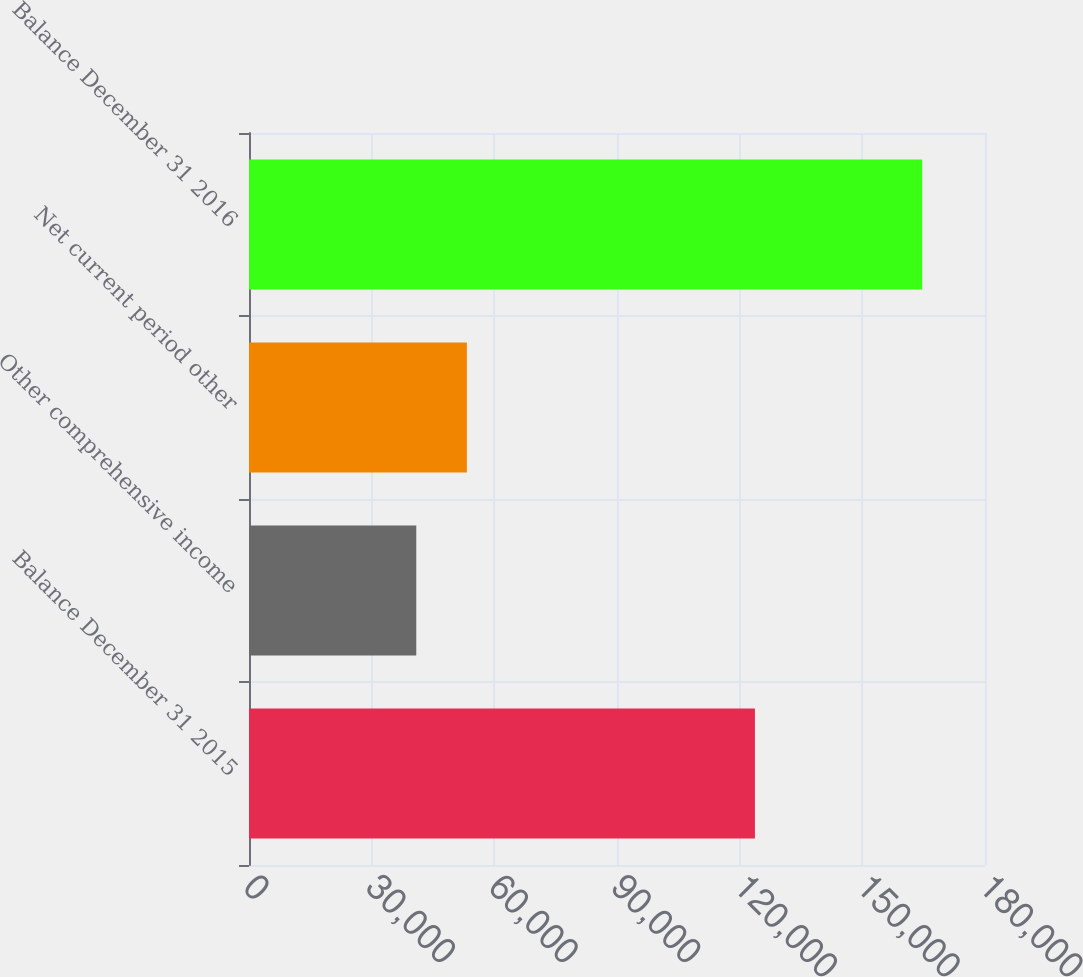Convert chart. <chart><loc_0><loc_0><loc_500><loc_500><bar_chart><fcel>Balance December 31 2015<fcel>Other comprehensive income<fcel>Net current period other<fcel>Balance December 31 2016<nl><fcel>123732<fcel>40911<fcel>53284.2<fcel>164643<nl></chart> 